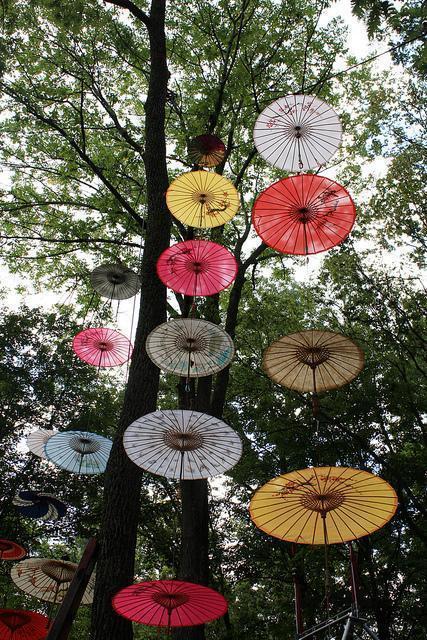What is near the colorful items?
Make your selection and explain in format: 'Answer: answer
Rationale: rationale.'
Options: Tree, tiger, onion, beach house. Answer: tree.
Rationale: These umbrellas are up in the trees. 